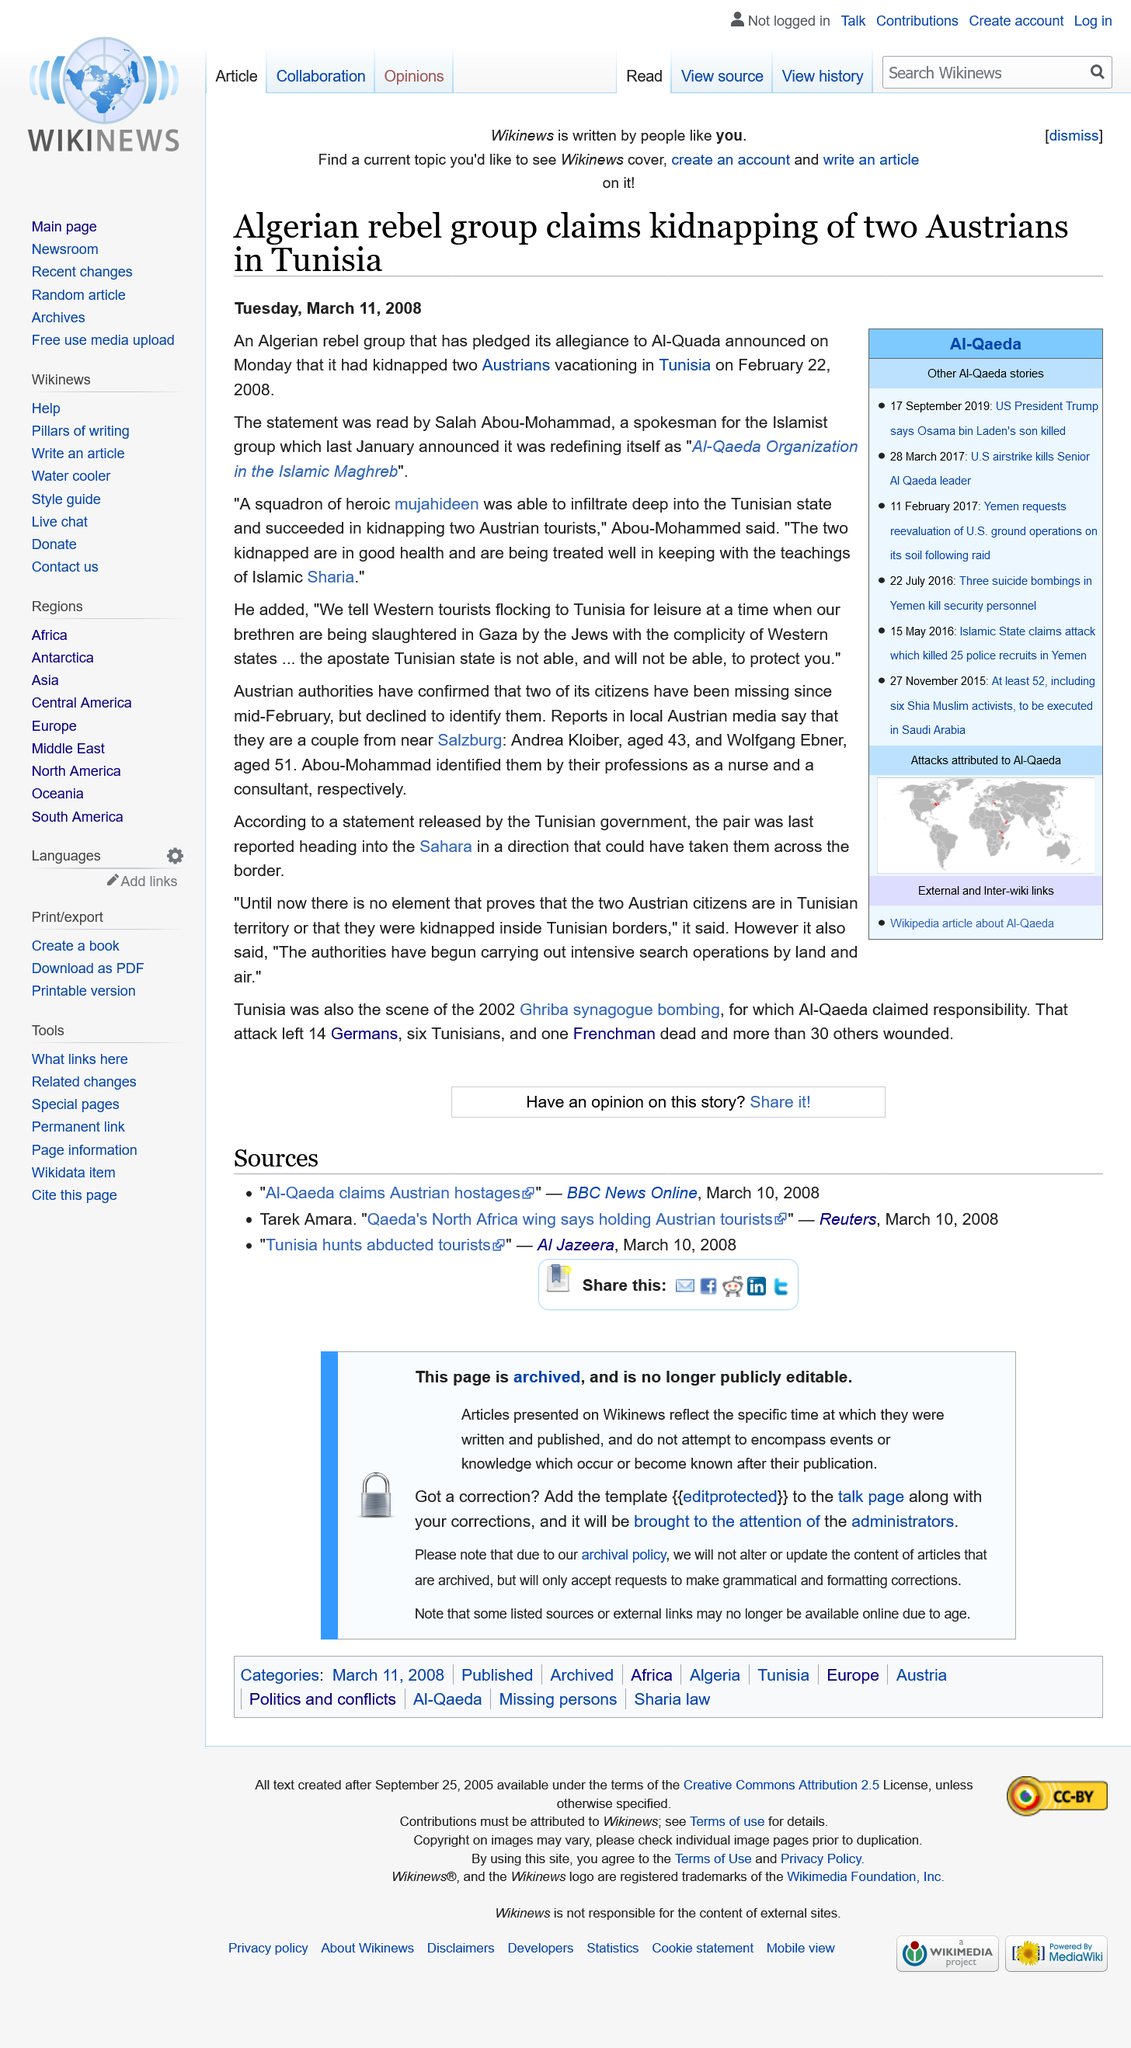Outline some significant characteristics in this image. The Algerian rebel group has pledged its allegiance to Al-Qaeda, which supports the group. Salah Abou-Mohammad, a member of the Algerian rebel group, announced the kidnapping of two Austrian tourists in Tunisia. On February 22, 2008, the Austrian tourists were kidnapped. 